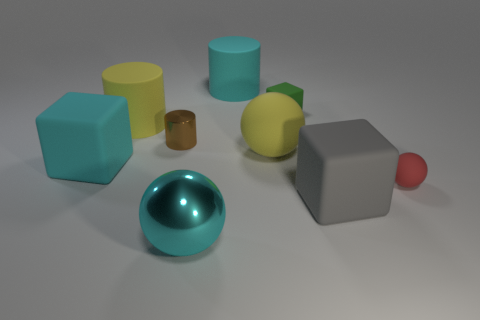Subtract all big cyan cubes. How many cubes are left? 2 Subtract 1 spheres. How many spheres are left? 2 Subtract all cylinders. How many objects are left? 6 Subtract all red cylinders. Subtract all purple spheres. How many cylinders are left? 3 Subtract all big rubber blocks. Subtract all matte balls. How many objects are left? 5 Add 6 large shiny spheres. How many large shiny spheres are left? 7 Add 2 large brown matte cylinders. How many large brown matte cylinders exist? 2 Subtract 0 red blocks. How many objects are left? 9 